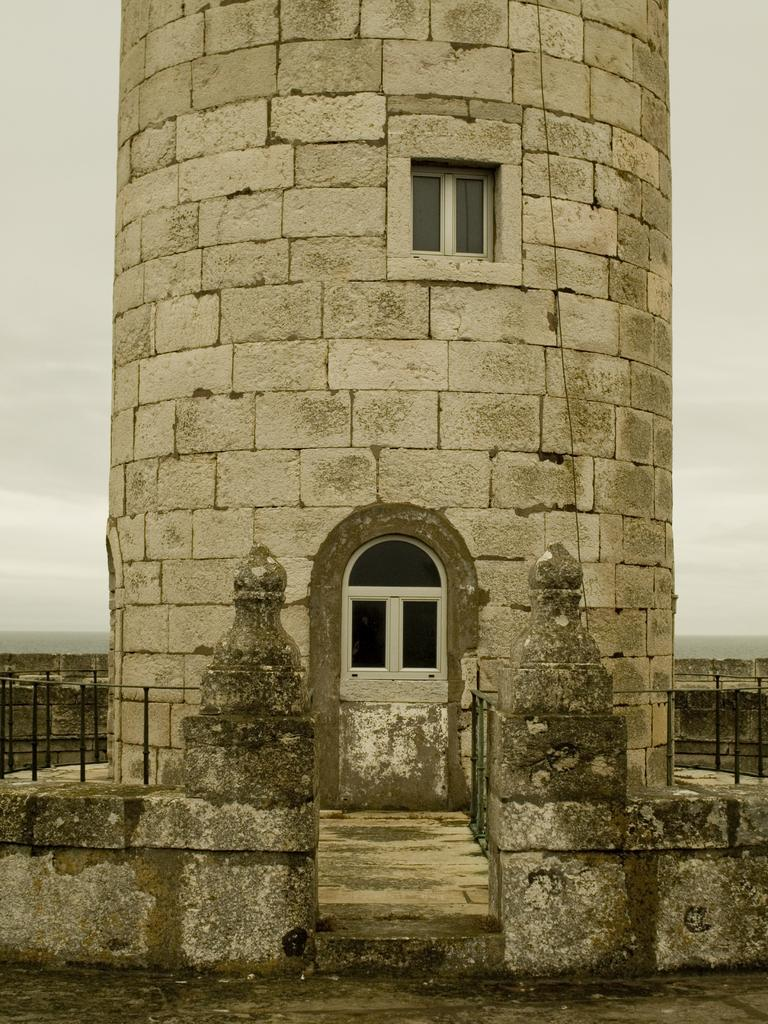What type of structure is present in the image? There is a building in the image. What feature can be seen on the building? The building has windows. What material is used to construct the wall of the building? The wall of the building is made of stone bricks. What is the condition of the sky in the image? There is a cloudy sky visible in the image. How does the thread connect the building to the stomach in the image? There is no thread or stomach present in the image; it only features a building and a cloudy sky. 